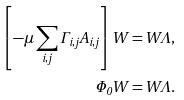Convert formula to latex. <formula><loc_0><loc_0><loc_500><loc_500>\left [ - \mu \sum _ { i , j } \Gamma _ { i , j } A _ { i , j } \right ] W = W \Lambda , \\ \Phi _ { 0 } W = W \Lambda . \\</formula> 